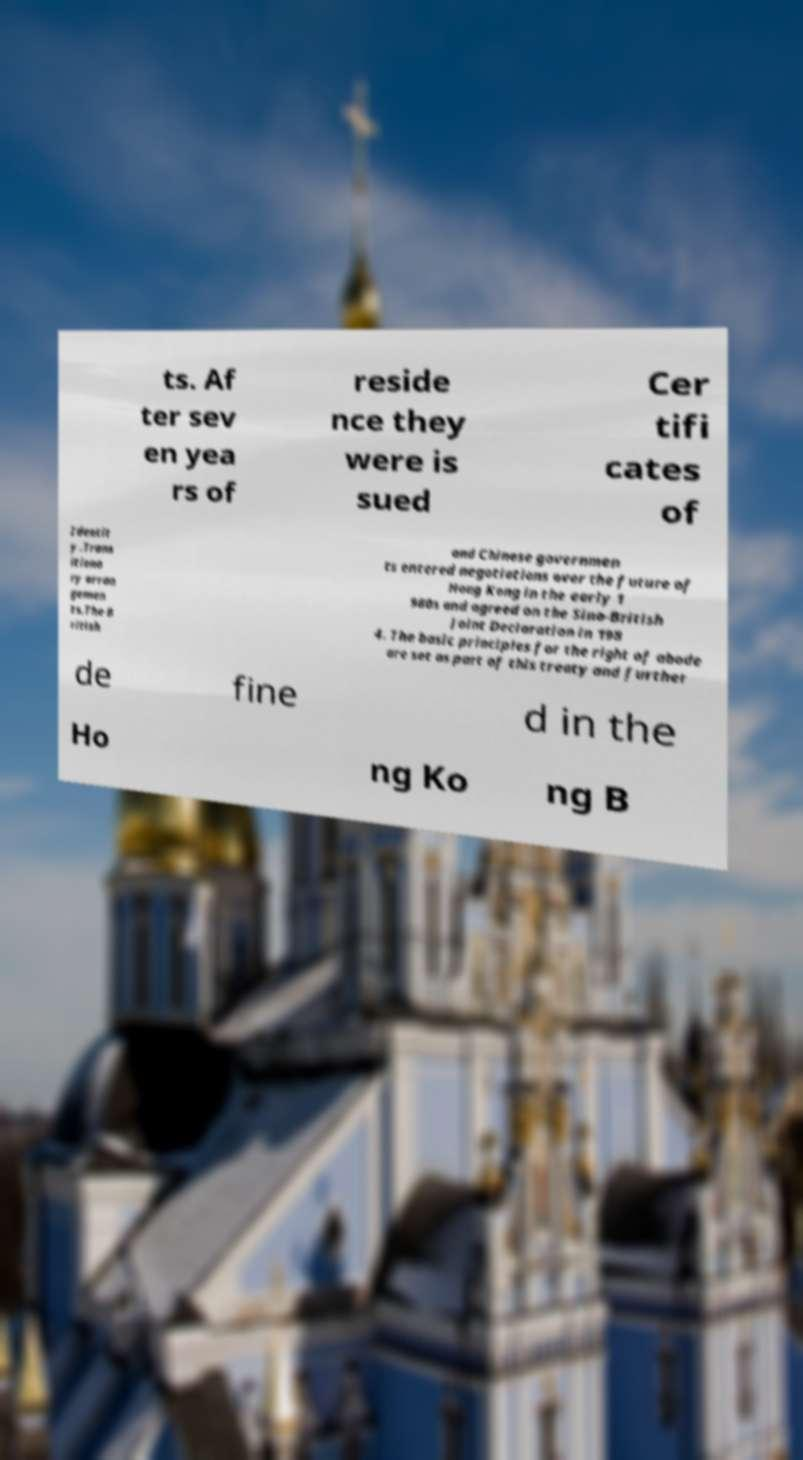Can you accurately transcribe the text from the provided image for me? ts. Af ter sev en yea rs of reside nce they were is sued Cer tifi cates of Identit y .Trans itiona ry arran gemen ts.The B ritish and Chinese governmen ts entered negotiations over the future of Hong Kong in the early 1 980s and agreed on the Sino-British Joint Declaration in 198 4. The basic principles for the right of abode are set as part of this treaty and further de fine d in the Ho ng Ko ng B 